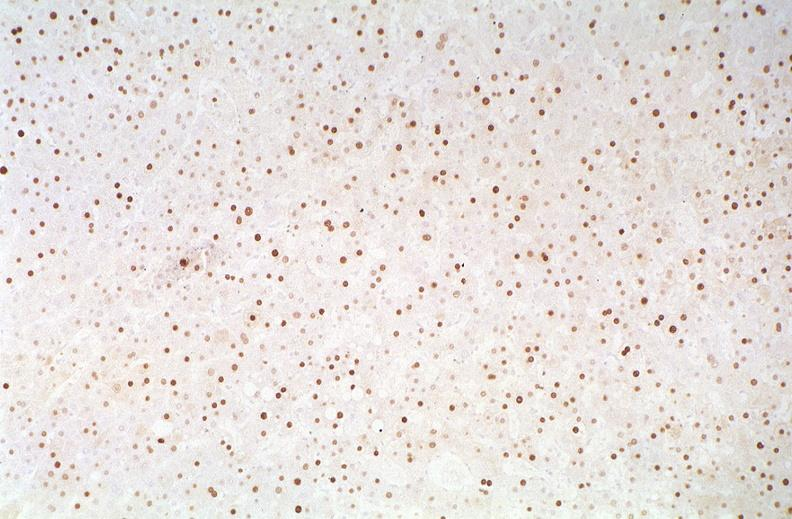does this image show hepatitis b virus, hbve antigen immunohistochemistry?
Answer the question using a single word or phrase. Yes 